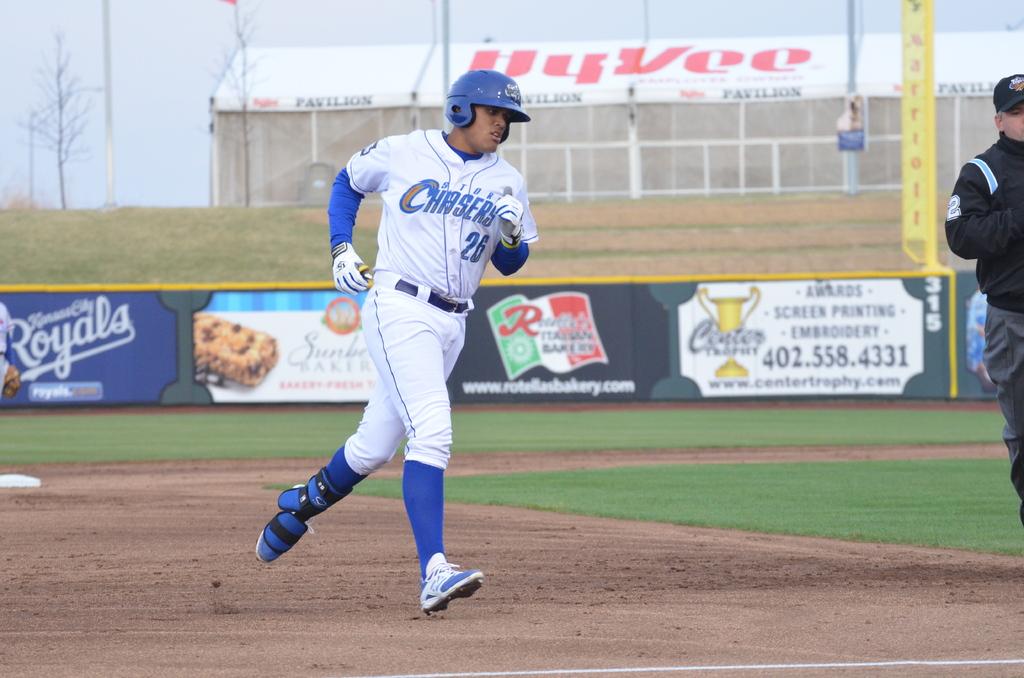What phone number is on the rightmost sign?
Make the answer very short. 402.558.4331. 